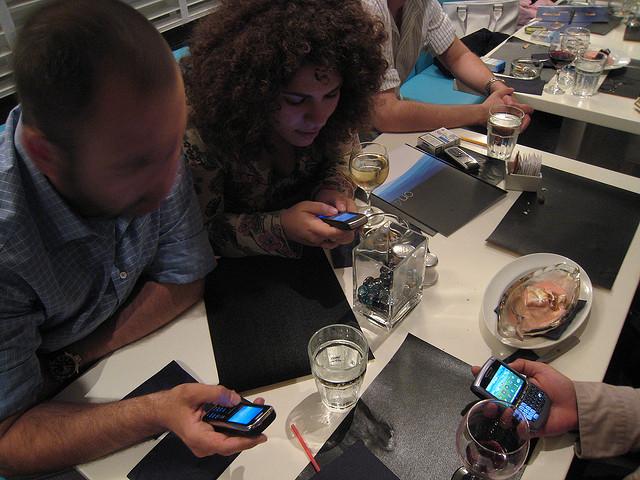Is someone's chin warmer than most?
Be succinct. Yes. How many people have phones?
Be succinct. 3. Do these three cherish each moment they have together?
Give a very brief answer. No. 